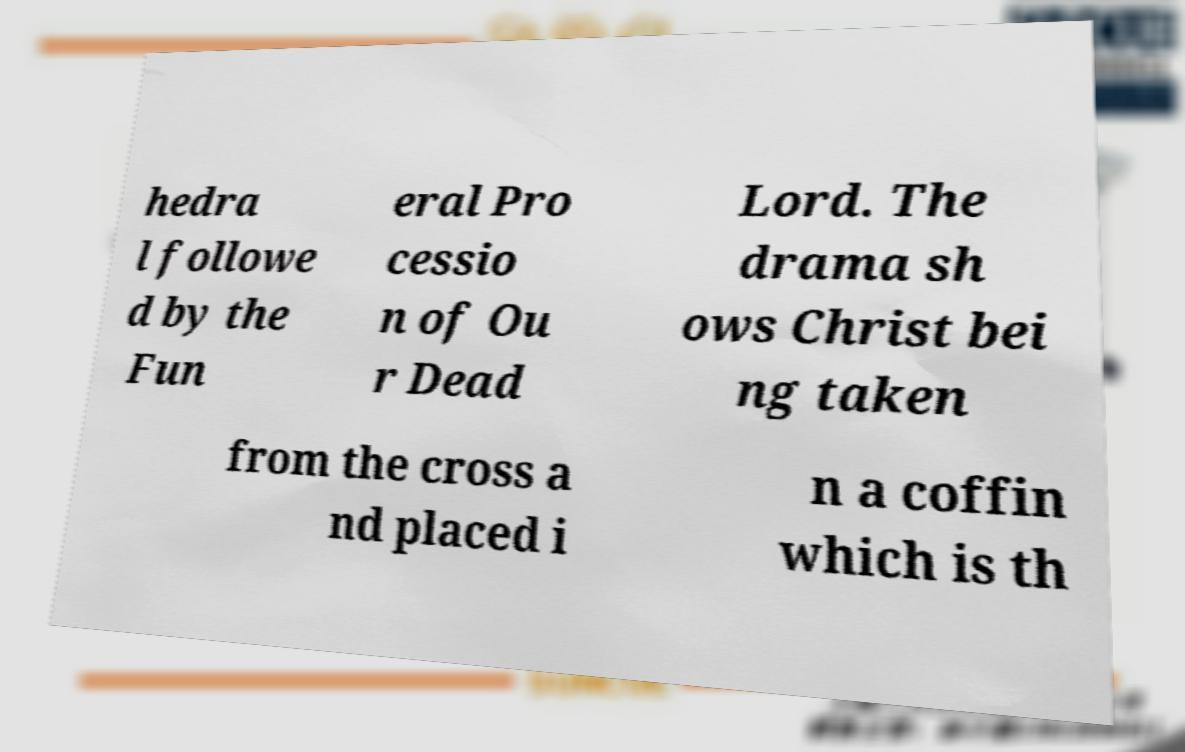I need the written content from this picture converted into text. Can you do that? hedra l followe d by the Fun eral Pro cessio n of Ou r Dead Lord. The drama sh ows Christ bei ng taken from the cross a nd placed i n a coffin which is th 